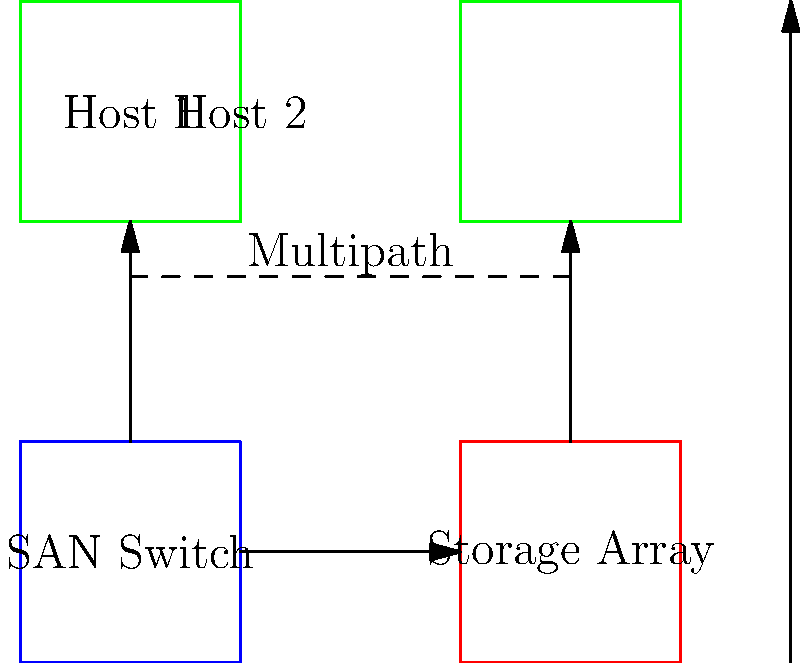In the given SAN topology for a virtualized environment, which configuration option would provide the best performance and redundancy for the storage connections between the hosts and the storage array? To determine the best configuration for improved virtualization performance and redundancy in a SAN environment, let's analyze the options step-by-step:

1. Single path: This configuration uses only one path between each host and the storage array. While simple, it lacks redundancy and can become a performance bottleneck.

2. Multipath: This configuration uses multiple paths between hosts and storage, as shown by the dashed line in the diagram. It provides better performance through load balancing and redundancy in case of path failure.

3. Active/Passive: In this configuration, one path is active while the other remains passive (standby). It provides redundancy but doesn't fully utilize all available paths for improved performance.

4. Active/Active: This configuration utilizes all available paths simultaneously, providing both load balancing for improved performance and redundancy.

For virtualization environments, where high performance and reliability are crucial, the best option is the Active/Active multipath configuration. This setup:

a) Maximizes bandwidth by using all available paths
b) Provides load balancing across paths
c) Offers redundancy in case of path failure
d) Optimizes I/O performance for virtual machines

In the context of a virtualization software vendor, implementing an Active/Active multipath configuration would allow for better utilization of SAN resources, improved VM performance, and enhanced reliability – all key factors in virtualized environments.
Answer: Active/Active multipath configuration 